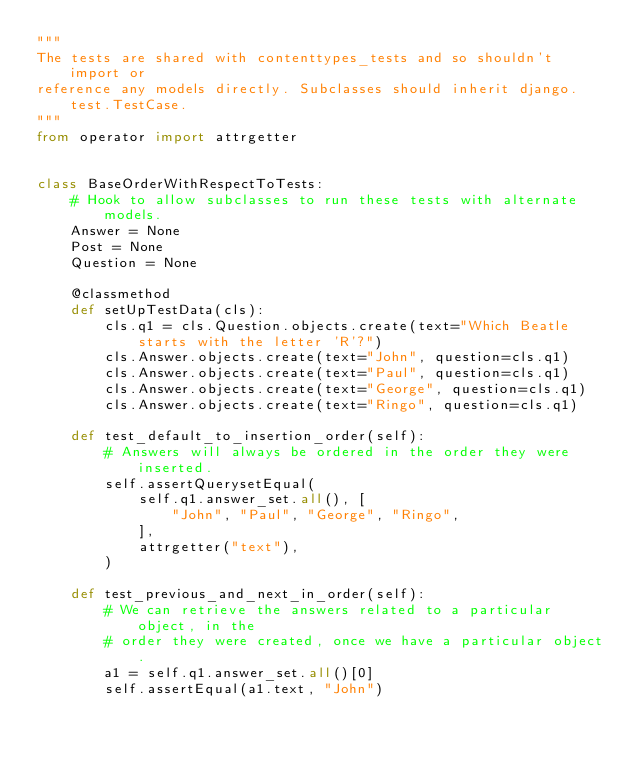<code> <loc_0><loc_0><loc_500><loc_500><_Python_>"""
The tests are shared with contenttypes_tests and so shouldn't import or
reference any models directly. Subclasses should inherit django.test.TestCase.
"""
from operator import attrgetter


class BaseOrderWithRespectToTests:
    # Hook to allow subclasses to run these tests with alternate models.
    Answer = None
    Post = None
    Question = None

    @classmethod
    def setUpTestData(cls):
        cls.q1 = cls.Question.objects.create(text="Which Beatle starts with the letter 'R'?")
        cls.Answer.objects.create(text="John", question=cls.q1)
        cls.Answer.objects.create(text="Paul", question=cls.q1)
        cls.Answer.objects.create(text="George", question=cls.q1)
        cls.Answer.objects.create(text="Ringo", question=cls.q1)

    def test_default_to_insertion_order(self):
        # Answers will always be ordered in the order they were inserted.
        self.assertQuerysetEqual(
            self.q1.answer_set.all(), [
                "John", "Paul", "George", "Ringo",
            ],
            attrgetter("text"),
        )

    def test_previous_and_next_in_order(self):
        # We can retrieve the answers related to a particular object, in the
        # order they were created, once we have a particular object.
        a1 = self.q1.answer_set.all()[0]
        self.assertEqual(a1.text, "John")</code> 